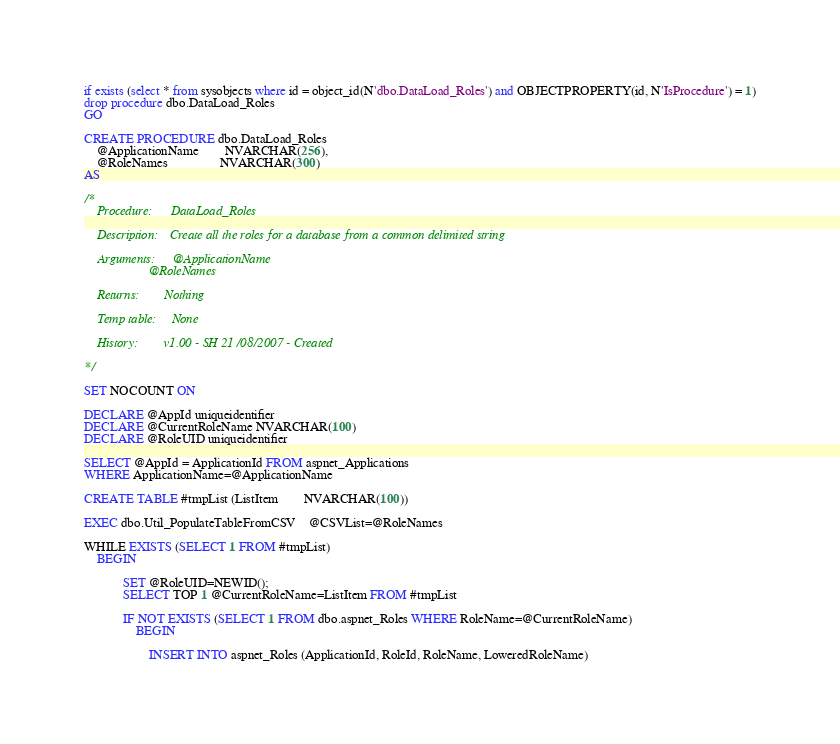<code> <loc_0><loc_0><loc_500><loc_500><_SQL_>if exists (select * from sysobjects where id = object_id(N'dbo.DataLoad_Roles') and OBJECTPROPERTY(id, N'IsProcedure') = 1)
drop procedure dbo.DataLoad_Roles
GO

CREATE PROCEDURE dbo.DataLoad_Roles
	@ApplicationName		NVARCHAR(256),
	@RoleNames				NVARCHAR(300)	
AS	

/* 	
	Procedure:		DataLoad_Roles
	
	Description:	Create all the roles for a database from a common delimited string

	Arguments:		@ApplicationName
					@RoleNames
					
	Returns:		Nothing

	Temp table:		None

	History:		v1.00 -	SH 21/08/2007 - Created
						   
*/

SET NOCOUNT ON

DECLARE @AppId uniqueidentifier
DECLARE @CurrentRoleName NVARCHAR(100)
DECLARE @RoleUID uniqueidentifier

SELECT @AppId = ApplicationId FROM aspnet_Applications
WHERE ApplicationName=@ApplicationName

CREATE TABLE #tmpList (ListItem		NVARCHAR(100))

EXEC dbo.Util_PopulateTableFromCSV	@CSVList=@RoleNames

WHILE EXISTS (SELECT 1 FROM #tmpList)
	BEGIN
	
			SET @RoleUID=NEWID();
			SELECT TOP 1 @CurrentRoleName=ListItem FROM #tmpList
			
			IF NOT EXISTS (SELECT 1 FROM dbo.aspnet_Roles WHERE RoleName=@CurrentRoleName)
				BEGIN
				
					INSERT INTO aspnet_Roles (ApplicationId, RoleId, RoleName, LoweredRoleName)</code> 